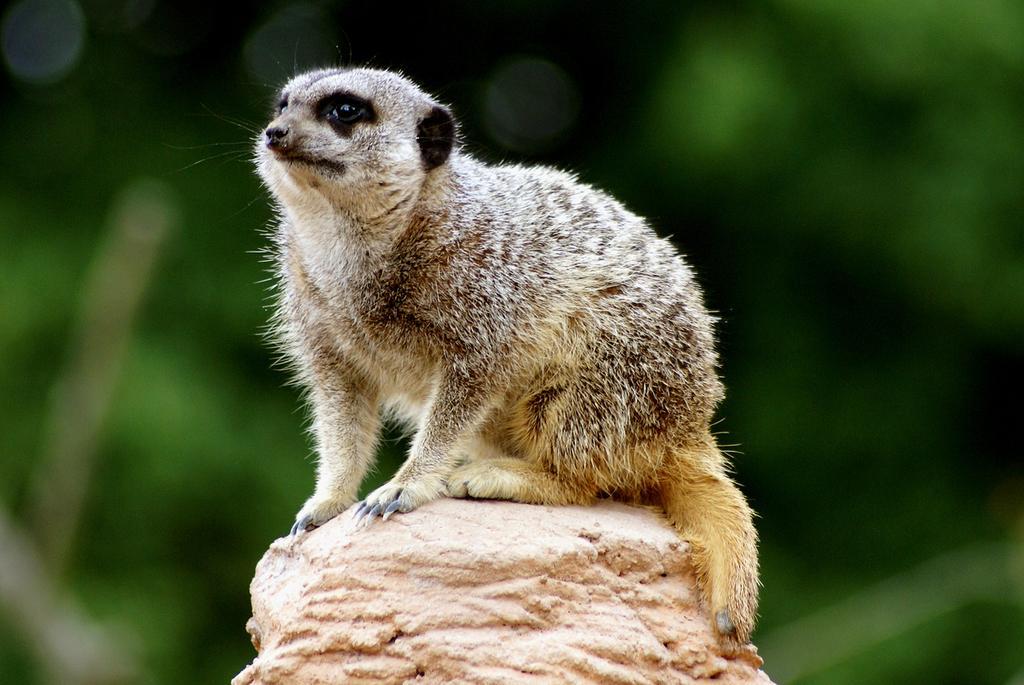Could you give a brief overview of what you see in this image? In this picture we can see an animal on the platform. In the background of the image it is blurry. 